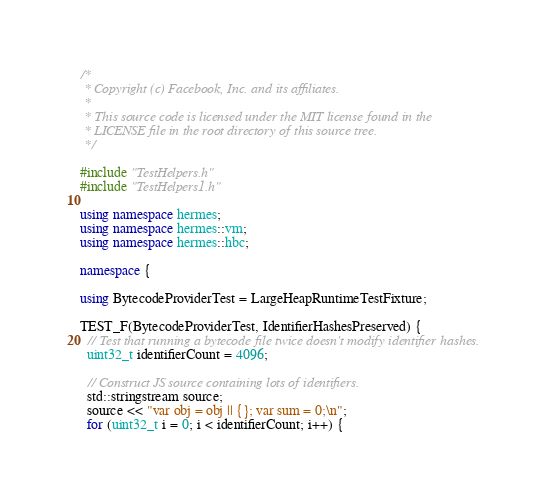Convert code to text. <code><loc_0><loc_0><loc_500><loc_500><_C++_>/*
 * Copyright (c) Facebook, Inc. and its affiliates.
 *
 * This source code is licensed under the MIT license found in the
 * LICENSE file in the root directory of this source tree.
 */

#include "TestHelpers.h"
#include "TestHelpers1.h"

using namespace hermes;
using namespace hermes::vm;
using namespace hermes::hbc;

namespace {

using BytecodeProviderTest = LargeHeapRuntimeTestFixture;

TEST_F(BytecodeProviderTest, IdentifierHashesPreserved) {
  // Test that running a bytecode file twice doesn't modify identifier hashes.
  uint32_t identifierCount = 4096;

  // Construct JS source containing lots of identifiers.
  std::stringstream source;
  source << "var obj = obj || {}; var sum = 0;\n";
  for (uint32_t i = 0; i < identifierCount; i++) {</code> 